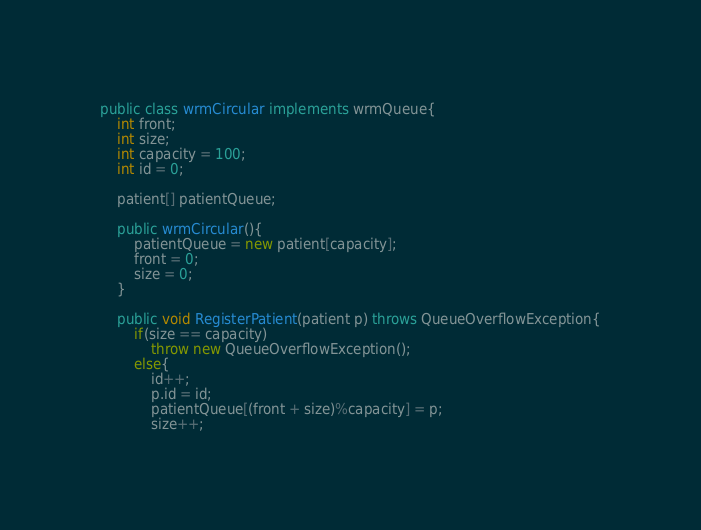<code> <loc_0><loc_0><loc_500><loc_500><_Java_>public class wrmCircular implements wrmQueue{
    int front;
    int size;
    int capacity = 100;
    int id = 0;
    
    patient[] patientQueue;

    public wrmCircular(){
        patientQueue = new patient[capacity];
        front = 0;
        size = 0;
    }

    public void RegisterPatient(patient p) throws QueueOverflowException{
        if(size == capacity)
            throw new QueueOverflowException();
        else{
            id++;
            p.id = id;
            patientQueue[(front + size)%capacity] = p;
            size++;</code> 